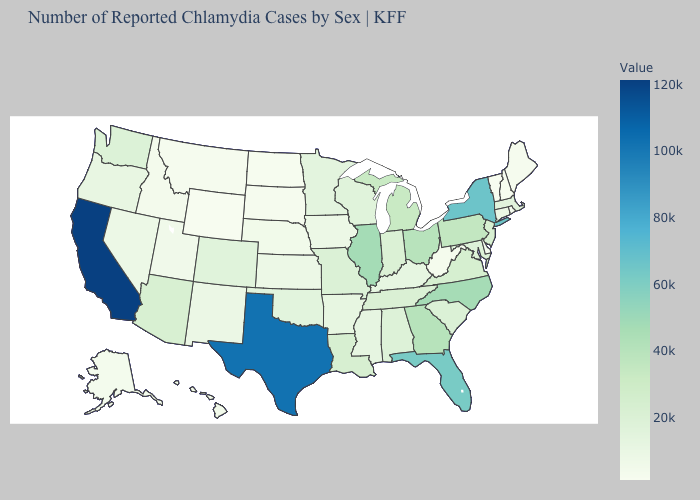Does Wyoming have the lowest value in the West?
Keep it brief. Yes. Does Vermont have the lowest value in the USA?
Answer briefly. Yes. Does South Carolina have a higher value than Rhode Island?
Write a very short answer. Yes. 